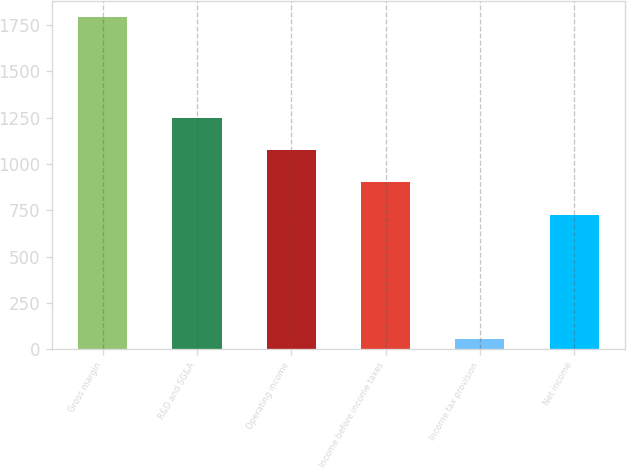Convert chart to OTSL. <chart><loc_0><loc_0><loc_500><loc_500><bar_chart><fcel>Gross margin<fcel>R&D and SG&A<fcel>Operating income<fcel>Income before income taxes<fcel>Income tax provision<fcel>Net income<nl><fcel>1791<fcel>1247.1<fcel>1073.4<fcel>899.7<fcel>54<fcel>726<nl></chart> 